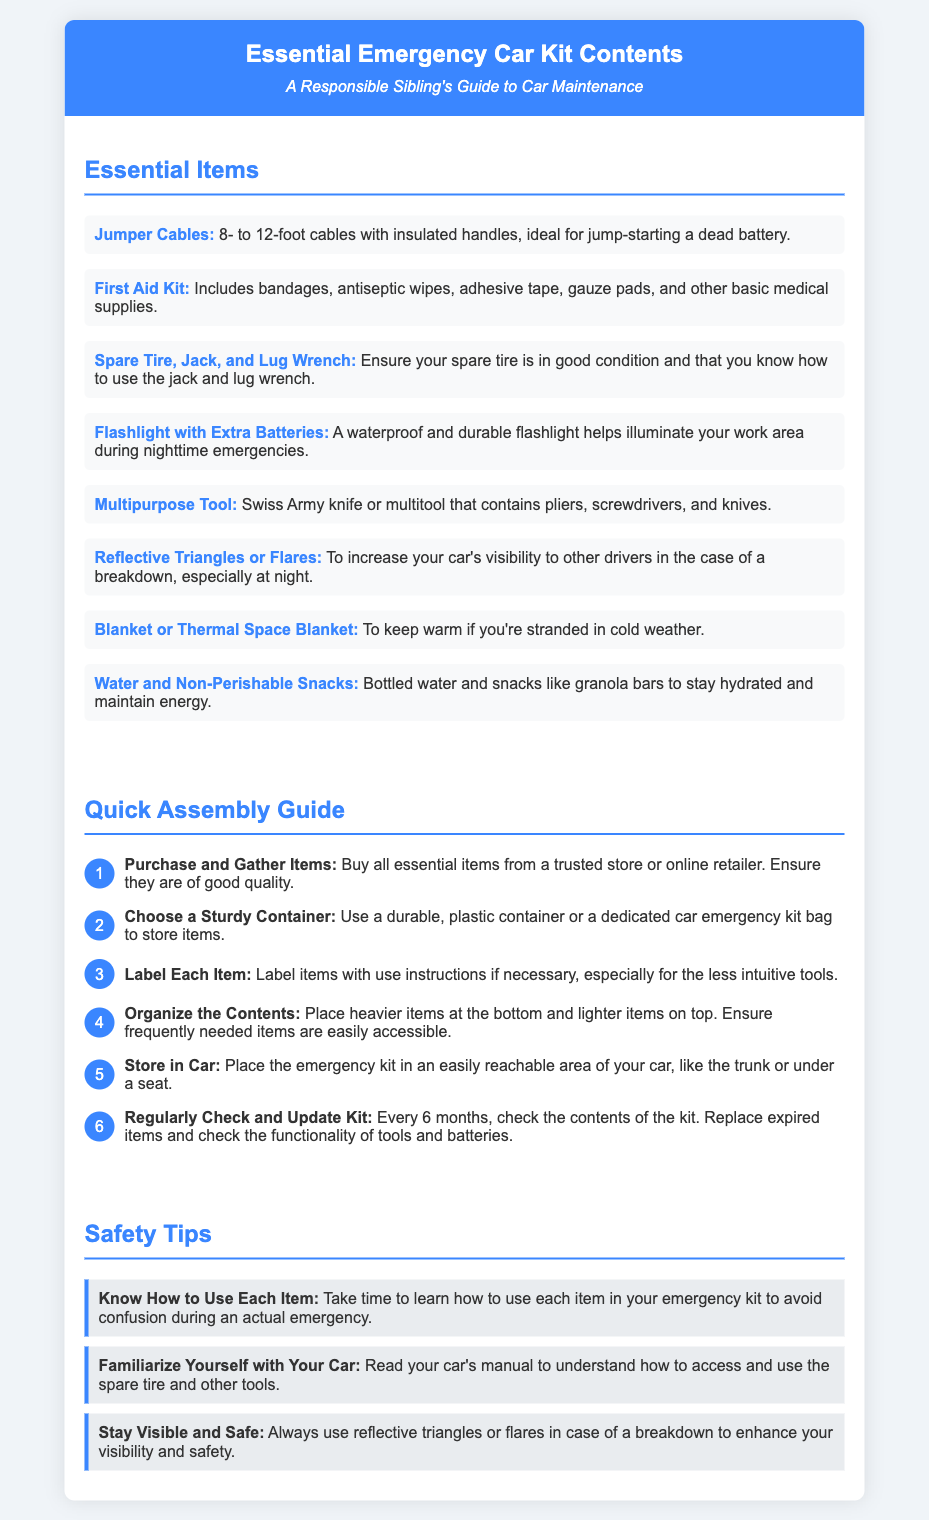what is the first item listed in the Essential Items section? The first item listed under Essential Items is Jumper Cables.
Answer: Jumper Cables how many items are included in the Essential Items section? There are eight items listed in the Essential Items section.
Answer: Eight what is the purpose of the flashlight in the emergency kit? The flashlight is used to illuminate your work area during nighttime emergencies.
Answer: Illuminate work area what is the last step in the Quick Assembly Guide? The last step is to regularly check and update the kit every 6 months.
Answer: Regularly check and update kit which item in the emergency kit can help keep you warm? The blanket or thermal space blanket helps keep warm if stranded.
Answer: Blanket or Thermal Space Blanket how often should you check the contents of your emergency kit? You should check the contents of your emergency kit every 6 months.
Answer: Every 6 months what is the color of the step number circles in the Quick Assembly Guide? The step number circles are colored blue.
Answer: Blue what should you do if you find expired items in the kit? You should replace expired items found in the kit.
Answer: Replace expired items 